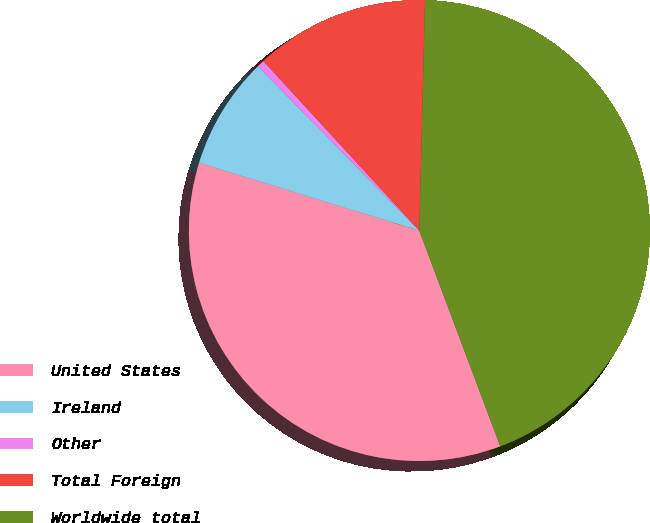Convert chart. <chart><loc_0><loc_0><loc_500><loc_500><pie_chart><fcel>United States<fcel>Ireland<fcel>Other<fcel>Total Foreign<fcel>Worldwide total<nl><fcel>35.47%<fcel>7.89%<fcel>0.52%<fcel>12.23%<fcel>43.88%<nl></chart> 